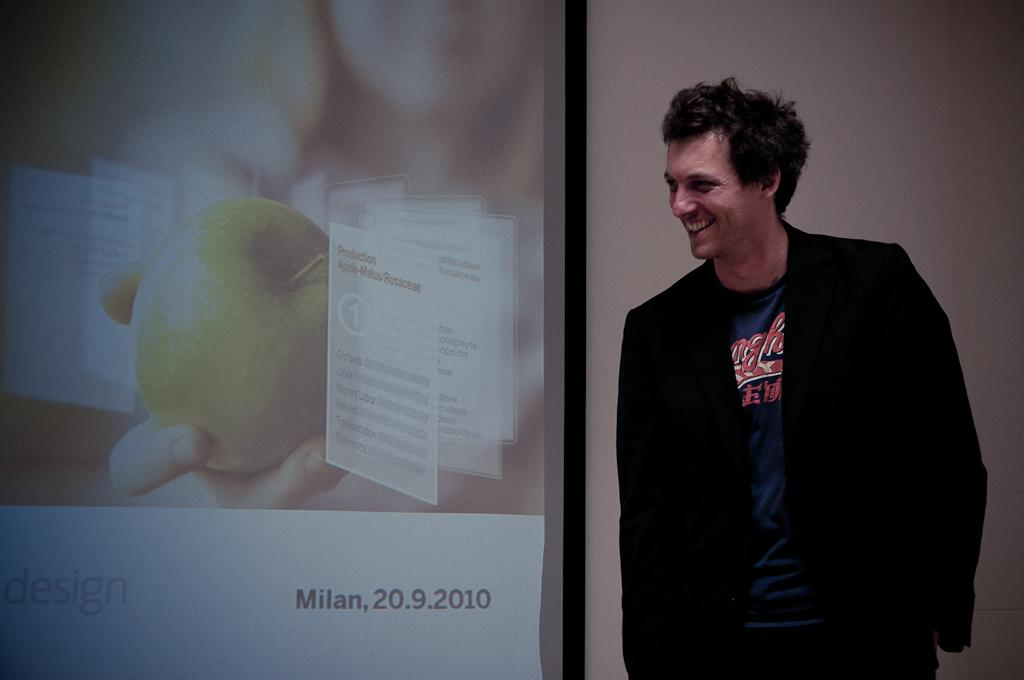Provide a one-sentence caption for the provided image. A man stands in front of a projector screen that says Milan, 20.9.2010 on it. 